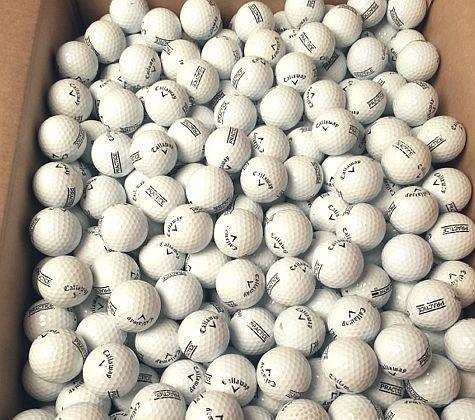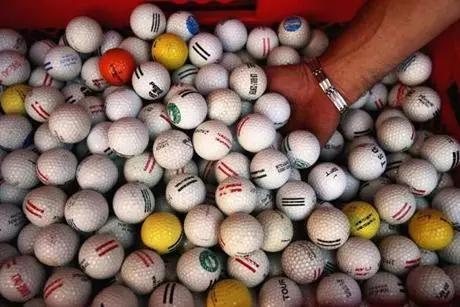The first image is the image on the left, the second image is the image on the right. For the images shown, is this caption "All the balls in the image on the right are white." true? Answer yes or no. No. The first image is the image on the left, the second image is the image on the right. Given the left and right images, does the statement "An image shows yellow and orange balls among white golf balls." hold true? Answer yes or no. Yes. 